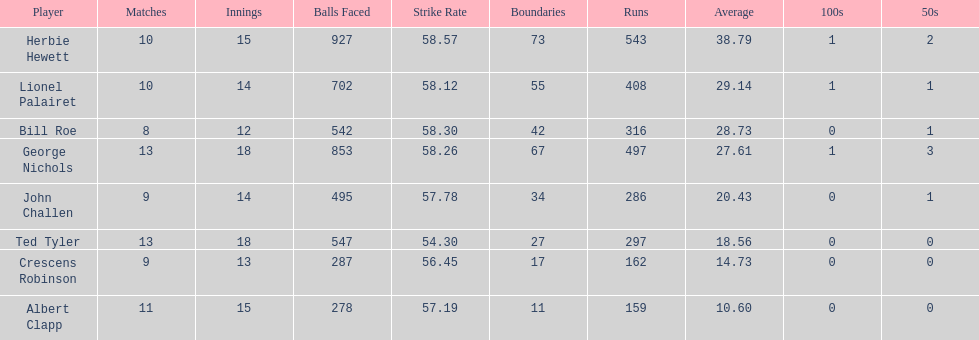How many more runs does john have than albert? 127. 